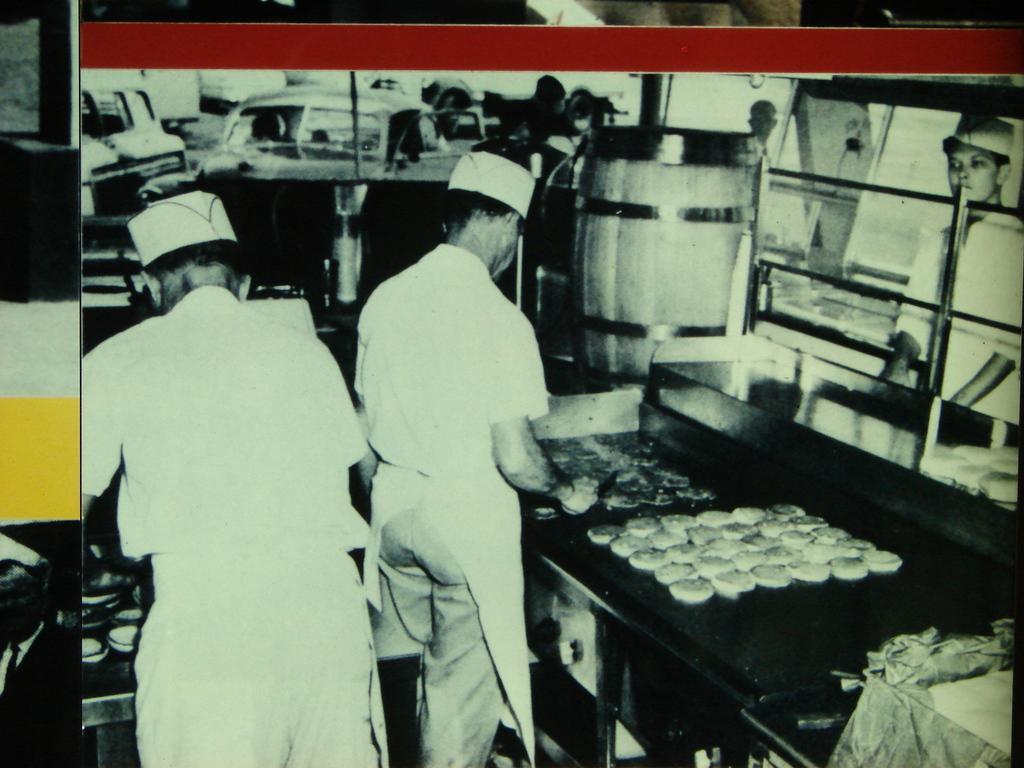Please provide a concise description of this image. This is a photo. In the center of the image we can see two people are standing and wearing the aprons, caps. In the background of the image we can see the vehicles, drum, rods, food items and some people are standing. 